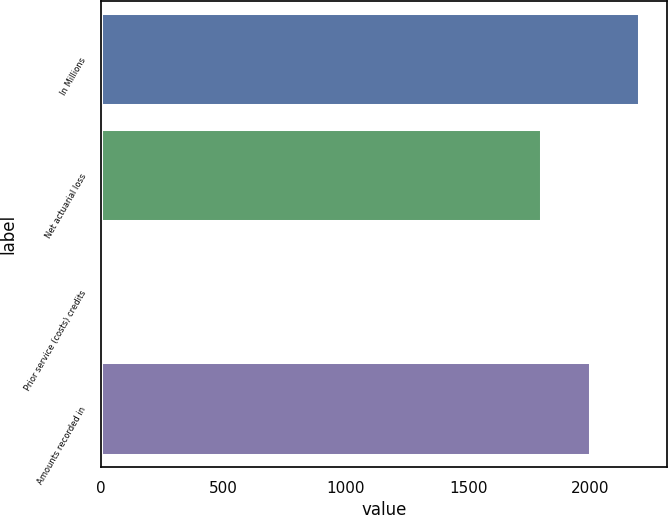Convert chart to OTSL. <chart><loc_0><loc_0><loc_500><loc_500><bar_chart><fcel>In Millions<fcel>Net actuarial loss<fcel>Prior service (costs) credits<fcel>Amounts recorded in<nl><fcel>2202.54<fcel>1801.5<fcel>7.8<fcel>2002.02<nl></chart> 